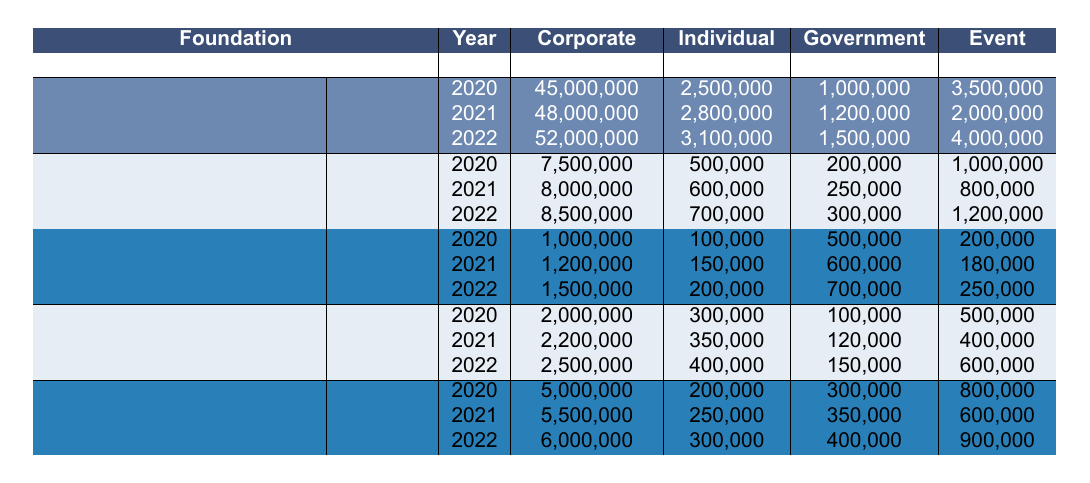What is the total funding for the Linux Foundation in 2021? The total funding is the sum of all funding sources for the Linux Foundation in 2021: Corporate Sponsorship (48,000,000) + Individual Donations (2,800,000) + Government Grants (1,200,000) + Event Revenue (2,000,000) = 54,000,000.
Answer: 54,000,000 How much did the OpenUK receive from Corporate Sponsorship in 2022? According to the table, OpenUK received 1,500,000 from Corporate Sponsorship in 2022.
Answer: 1,500,000 Which foundation had the highest Individual Donations in 2020? By comparing the Individual Donations in 2020: Linux Foundation (2,500,000), Apache Software Foundation (500,000), OpenUK (100,000), GNOME Foundation (300,000), and Eclipse Foundation (200,000), the Linux Foundation had the highest.
Answer: Linux Foundation What was the average Event Revenue for the GNOME Foundation from 2020 to 2022? The Event Revenue values for GNOME Foundation are 500,000 (2020), 400,000 (2021), and 600,000 (2022). The total is 500,000 + 400,000 + 600,000 = 1,500,000. The average is 1,500,000 / 3 = 500,000.
Answer: 500,000 Did the funding from Government Grants for Apache Software Foundation increase from 2020 to 2022? In 2020, Government Grants were 200,000. In 2022, they increased to 300,000. Thus, there is an increase.
Answer: Yes Which foundation saw the largest increase in Corporate Sponsorship from 2020 to 2022? Looking at the Corporate Sponsorship values: Linux Foundation increased from 45,000,000 to 52,000,000 (7,000,000 increase), Apache Software Foundation from 7,500,000 to 8,500,000 (1,000,000 increase), OpenUK from 1,000,000 to 1,500,000 (500,000 increase), GNOME Foundation from 2,000,000 to 2,500,000 (500,000 increase), and Eclipse Foundation from 5,000,000 to 6,000,000 (1,000,000 increase). The largest increase is 7,000,000 by Linux Foundation.
Answer: Linux Foundation What is the difference in total funding between the Eclipse Foundation and the Linux Foundation in 2020? For the Eclipse Foundation in 2020, total funding is: 5,000,000 + 200,000 + 300,000 + 800,000 = 6,300,000. For the Linux Foundation in 2020, total funding is: 45,000,000 + 2,500,000 + 1,000,000 + 3,500,000 = 52,000,000. The difference is 52,000,000 - 6,300,000 = 45,700,000.
Answer: 45,700,000 What was the percentage increase of Government Grants for OpenUK from 2020 to 2022? Government Grants for OpenUK in 2020 were 500,000 and in 2022 they were 700,000. The increase is 700,000 - 500,000 = 200,000. The percentage increase is (200,000 / 500,000) * 100 = 40%.
Answer: 40% Which country had the highest funding sources total in the year 2021? Summing the total funding for each foundation in 2021: Linux Foundation (54,000,000), Apache Software Foundation (8,850,000), OpenUK (2,130,000), GNOME Foundation (2,670,000), and Eclipse Foundation (5,850,000). USA totals to 54,000,000 + 8,850,000 + 2,670,000 = 65,520,000, vs UK (2,130,000) and Canada (5,850,000). Thus, the USA had the highest.
Answer: USA 